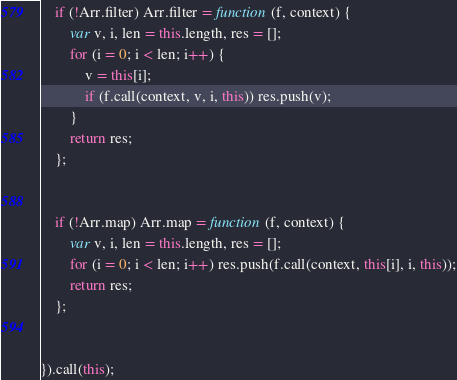<code> <loc_0><loc_0><loc_500><loc_500><_JavaScript_>    if (!Arr.filter) Arr.filter = function (f, context) {
        var v, i, len = this.length, res = [];
        for (i = 0; i < len; i++) {
            v = this[i];
            if (f.call(context, v, i, this)) res.push(v);
        }
        return res;
    };


    if (!Arr.map) Arr.map = function (f, context) {
        var v, i, len = this.length, res = [];
        for (i = 0; i < len; i++) res.push(f.call(context, this[i], i, this));
        return res;
    };


}).call(this);      </code> 